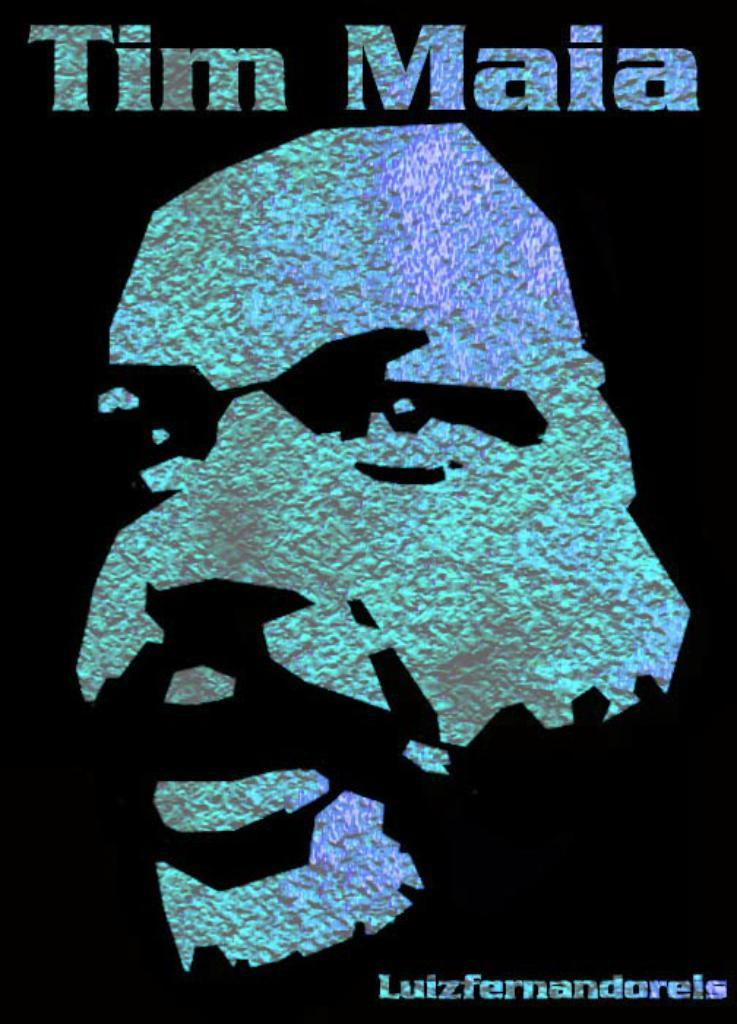<image>
Share a concise interpretation of the image provided. A cover is titled Tim Maia and has a black background. 